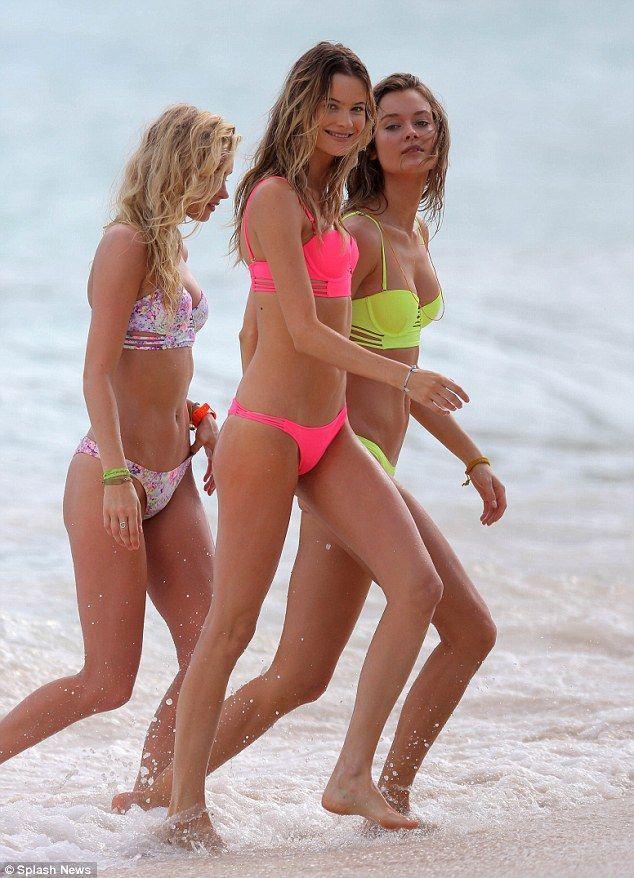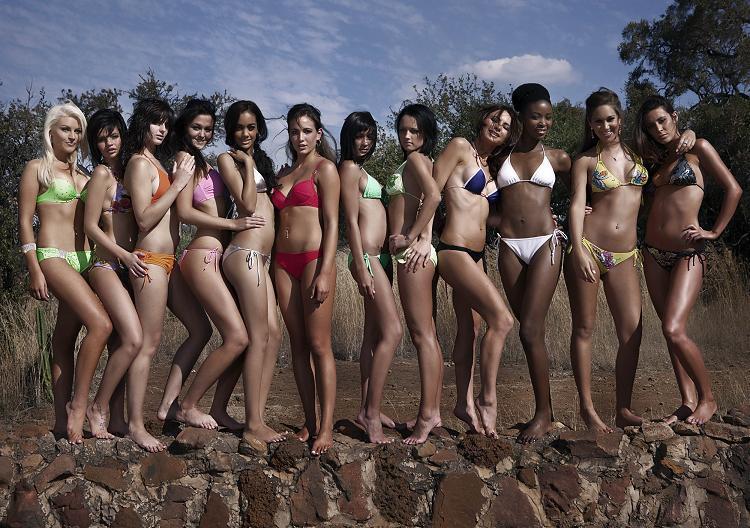The first image is the image on the left, the second image is the image on the right. For the images shown, is this caption "One image shows four bikini models in sunglasses standing in front of the ocean." true? Answer yes or no. No. The first image is the image on the left, the second image is the image on the right. For the images displayed, is the sentence "There are eight or less women." factually correct? Answer yes or no. No. 